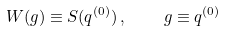Convert formula to latex. <formula><loc_0><loc_0><loc_500><loc_500>W ( g ) \equiv S ( q ^ { ( 0 ) } ) \, , \quad g \equiv q ^ { ( 0 ) }</formula> 